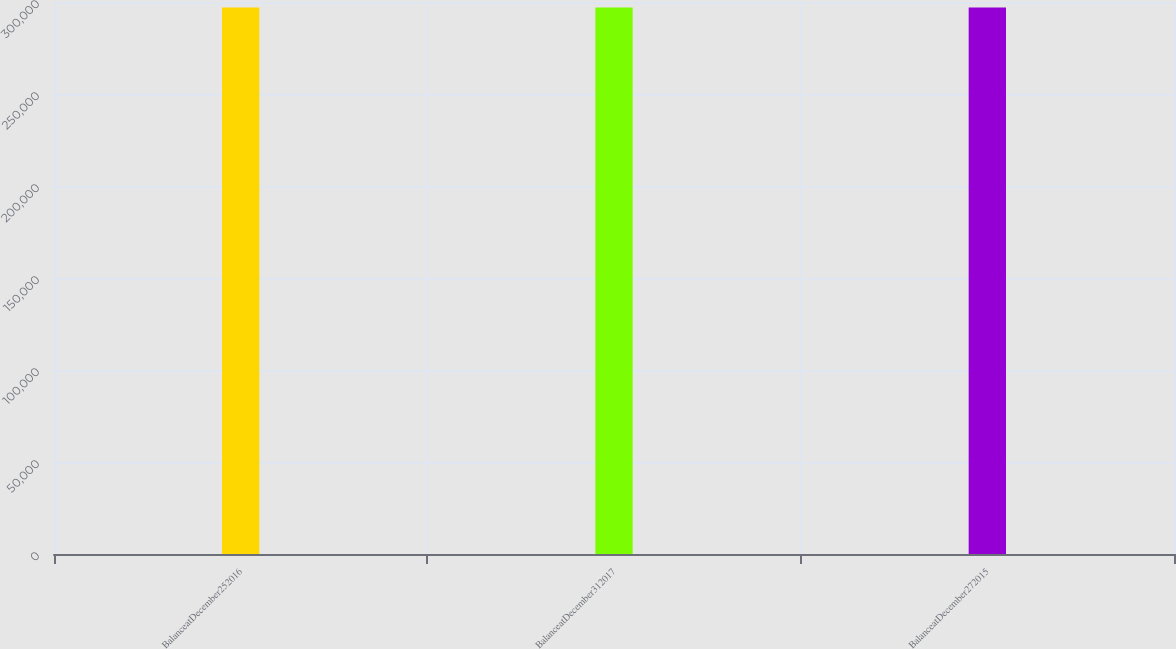Convert chart. <chart><loc_0><loc_0><loc_500><loc_500><bar_chart><fcel>BalanceatDecember252016<fcel>BalanceatDecember312017<fcel>BalanceatDecember272015<nl><fcel>296978<fcel>296978<fcel>296978<nl></chart> 